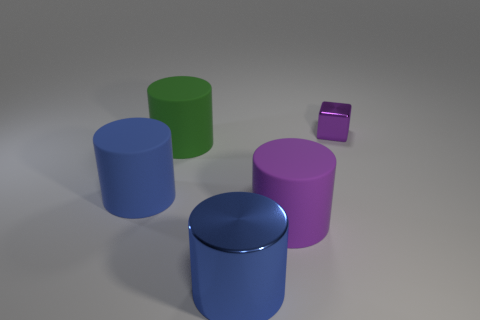There is a blue thing in front of the purple object that is to the left of the purple cube; what is its size? The size of the blue object, which appears to be a cylindrical shape positioned in front of a purple round-edged object and to the left of the smaller purple cube, is relatively large compared to the cube and can be described as medium in the given context. 